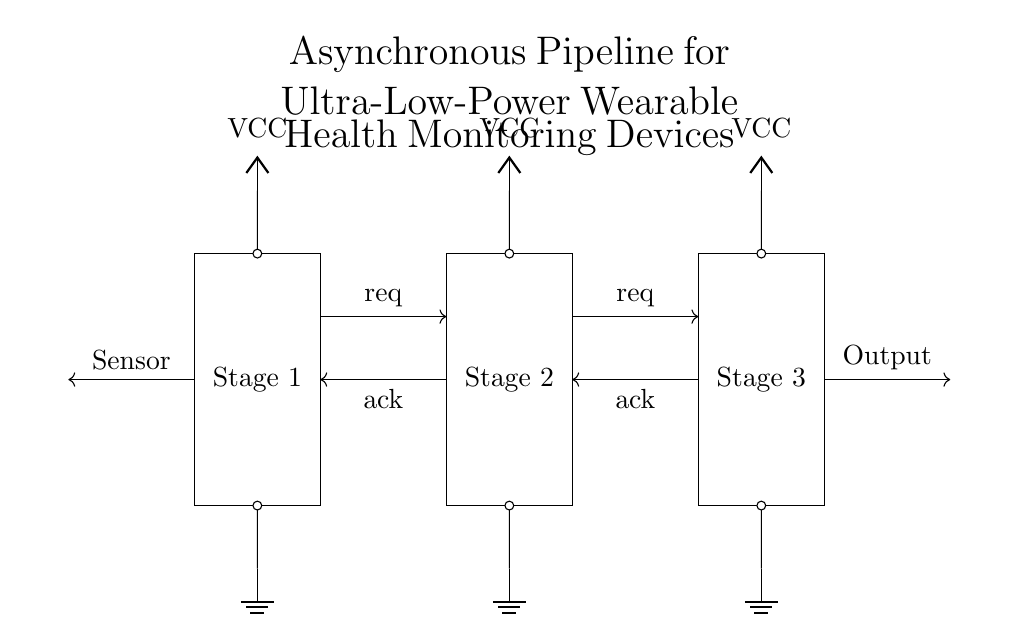What are the stages in this pipeline? The circuit has three stages labeled 'Stage 1', 'Stage 2', and 'Stage 3', indicating its sequential processing structure.
Answer: Stage 1, Stage 2, Stage 3 What type of signals are used for communication between stages? The diagram shows asynchronous handshake signals 'req' (request) and 'ack' (acknowledge) for communication, indicated by arrows between the stages.
Answer: req, ack What is the power source for this circuit? The circuit includes 'VCC' symbols at each stage, indicating that a power source of positive voltage is used for operation.
Answer: VCC How many grounds are indicated in the circuit? There are three ground symbols shown at each stage of the circuit, which means they all share a common reference point.
Answer: Three Why is the asynchronous design chosen for this circuit? The asynchronous design allows for low power consumption, making it suitable for wearable health monitoring devices that require efficient operation while minimizing energy use.
Answer: Low power consumption What component receives input from the sensor? The circuit's input is connected to 'Stage 1', which denotes that this stage receives data directly from the sensor.
Answer: Stage 1 What is the output of the pipeline? The output is shown as an arrow from 'Stage 3' to 'Output', indicating that processed information is sent out from the final stage of the pipeline.
Answer: Output 